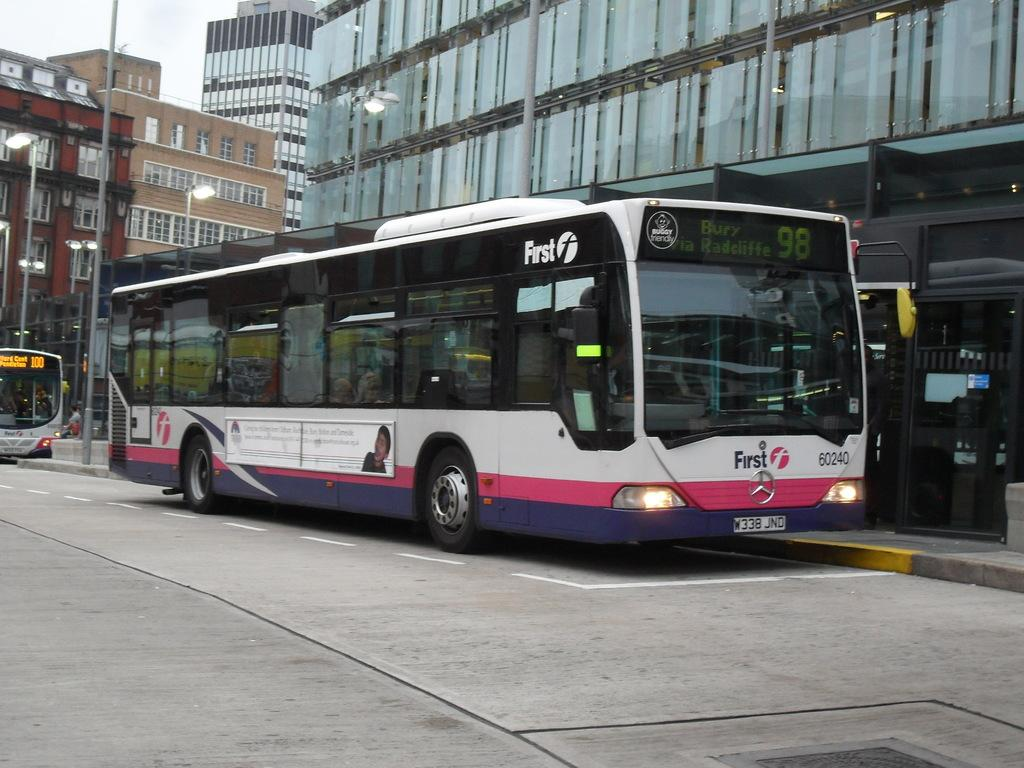Provide a one-sentence caption for the provided image. A white,, pink, and purple bus with the license plate W338 JND. 